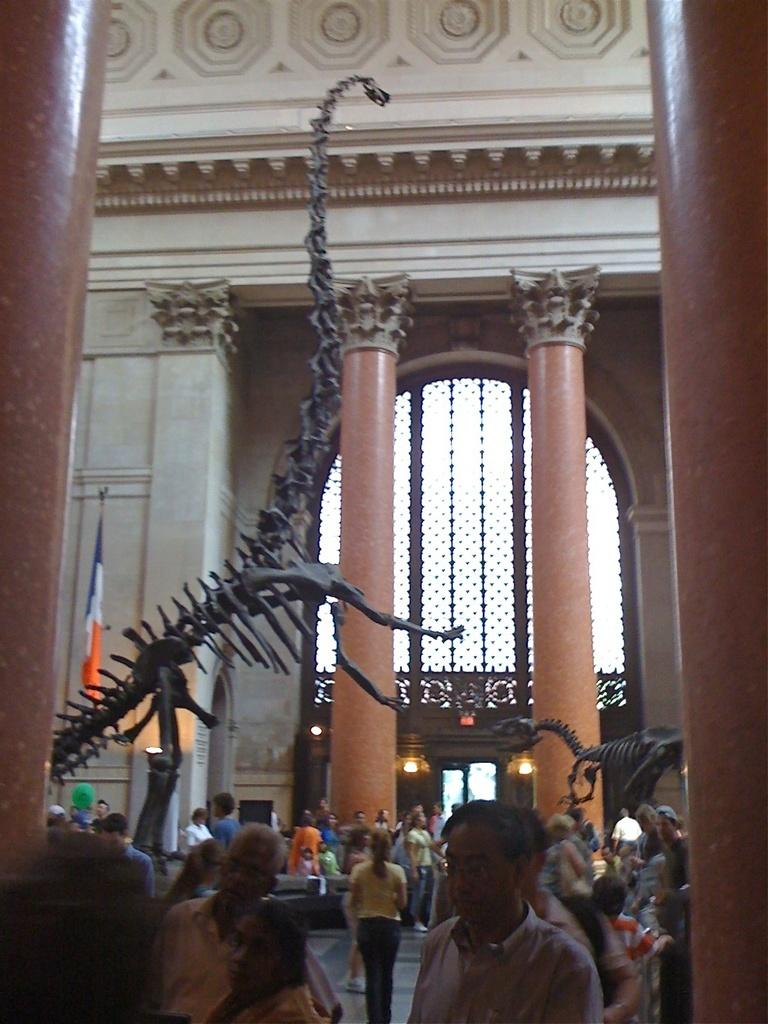What type of objects can be seen in the image? There are statues in the image. Are there any living beings in the image? Yes, there are people in the image. What can be seen in the distance in the image? There is a building in the background of the image. How many brothers are depicted in the farm scene in the image? There is no farm scene or brothers present in the image; it features statues and people with a building in the background. 